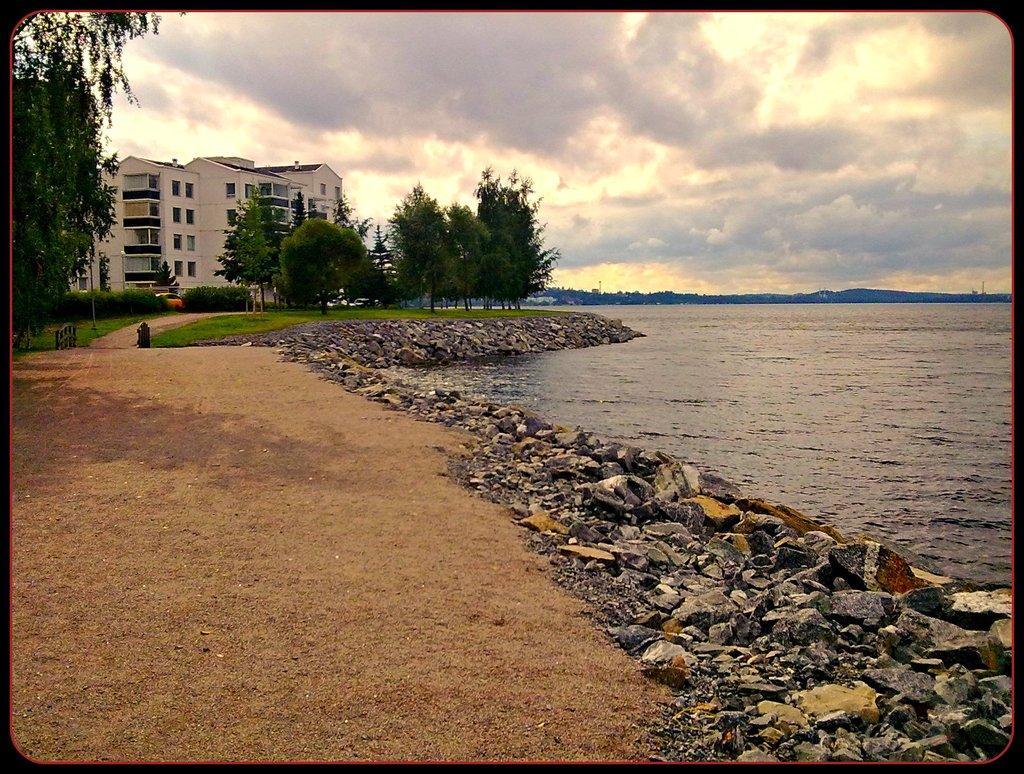In one or two sentences, can you explain what this image depicts? In this image, we can see ground, stones, water. Background there are so many trees, buildings, walls and cloudy sky. 